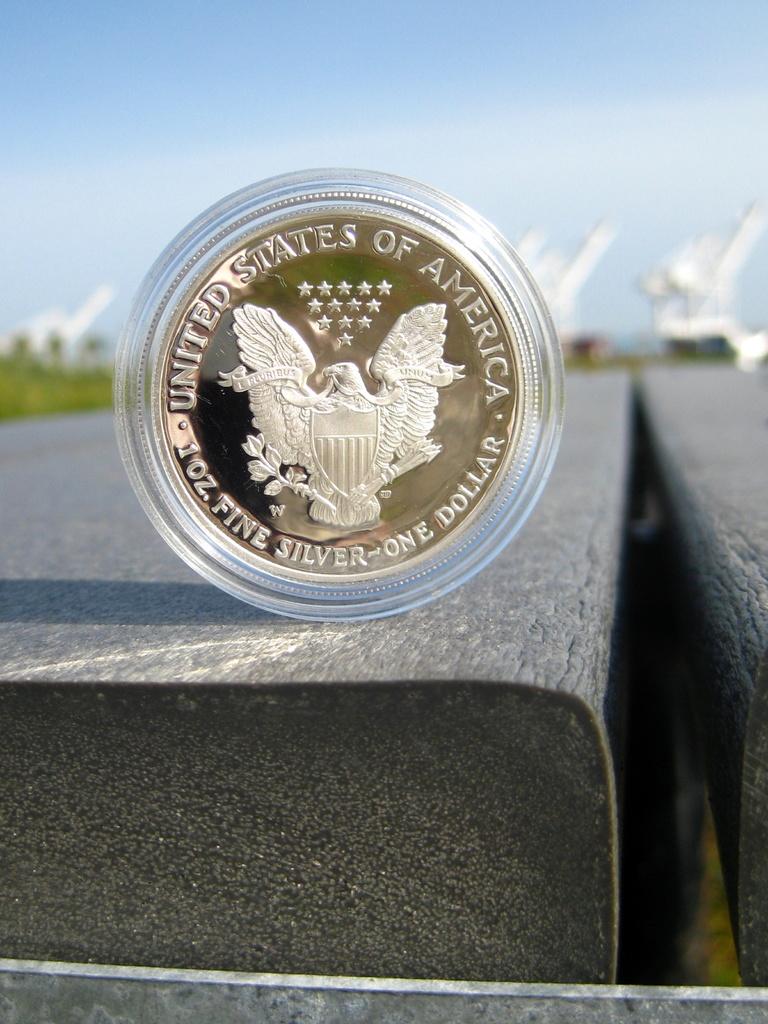What united country is written on the coin?
Provide a succinct answer. United states of america. 